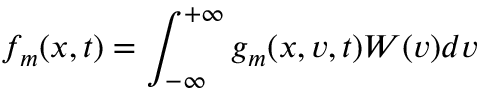Convert formula to latex. <formula><loc_0><loc_0><loc_500><loc_500>f _ { m } ( x , t ) = \int _ { - \infty } ^ { + \infty } g _ { m } ( x , v , t ) W ( v ) d v</formula> 